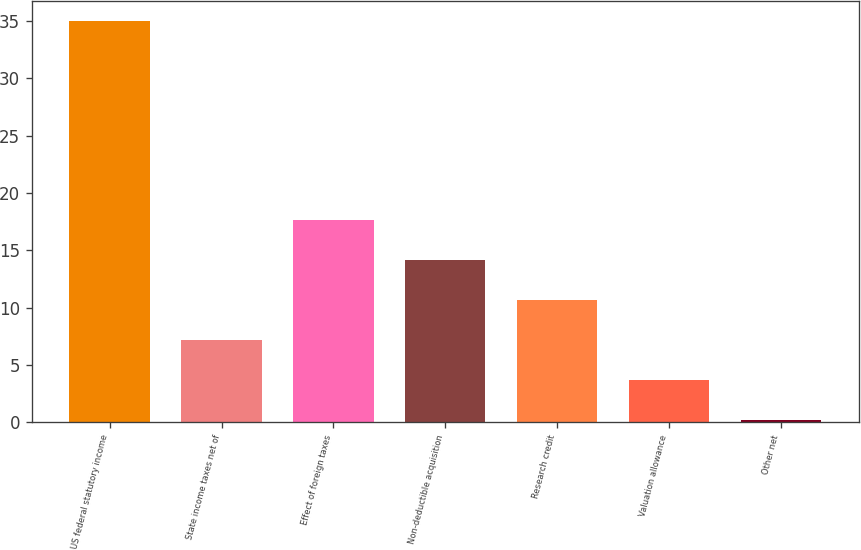Convert chart to OTSL. <chart><loc_0><loc_0><loc_500><loc_500><bar_chart><fcel>US federal statutory income<fcel>State income taxes net of<fcel>Effect of foreign taxes<fcel>Non-deductible acquisition<fcel>Research credit<fcel>Valuation allowance<fcel>Other net<nl><fcel>35<fcel>7.16<fcel>17.6<fcel>14.12<fcel>10.64<fcel>3.68<fcel>0.2<nl></chart> 